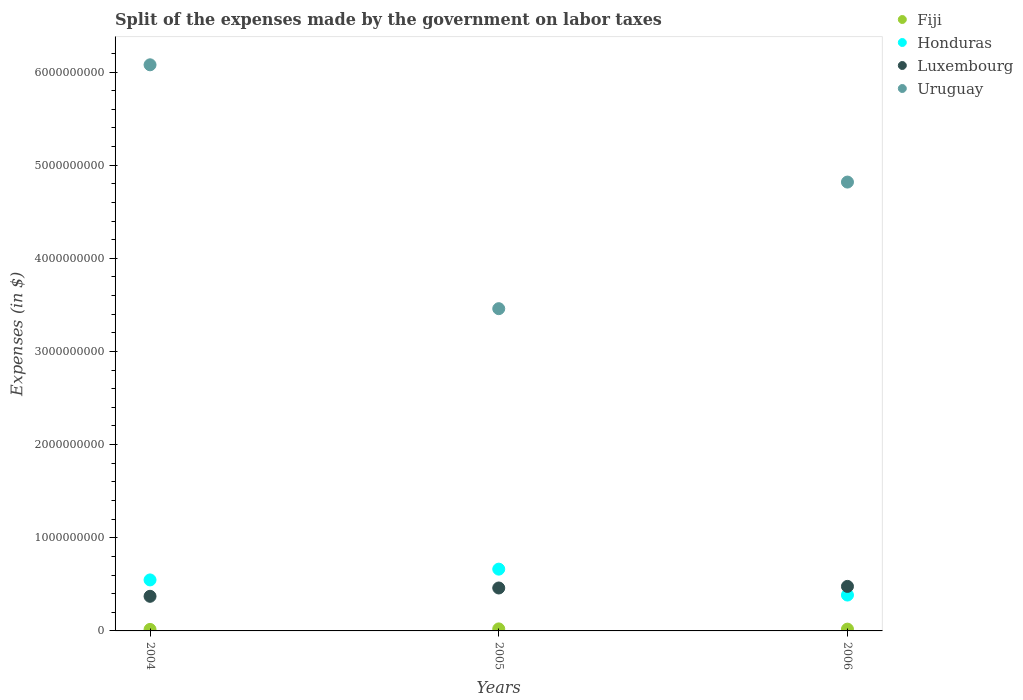How many different coloured dotlines are there?
Offer a very short reply. 4. What is the expenses made by the government on labor taxes in Luxembourg in 2006?
Keep it short and to the point. 4.78e+08. Across all years, what is the maximum expenses made by the government on labor taxes in Uruguay?
Your answer should be compact. 6.08e+09. Across all years, what is the minimum expenses made by the government on labor taxes in Honduras?
Provide a succinct answer. 3.85e+08. In which year was the expenses made by the government on labor taxes in Uruguay maximum?
Make the answer very short. 2004. In which year was the expenses made by the government on labor taxes in Fiji minimum?
Provide a succinct answer. 2004. What is the total expenses made by the government on labor taxes in Honduras in the graph?
Give a very brief answer. 1.60e+09. What is the difference between the expenses made by the government on labor taxes in Honduras in 2004 and that in 2005?
Offer a terse response. -1.16e+08. What is the difference between the expenses made by the government on labor taxes in Uruguay in 2006 and the expenses made by the government on labor taxes in Honduras in 2004?
Keep it short and to the point. 4.27e+09. What is the average expenses made by the government on labor taxes in Fiji per year?
Your answer should be very brief. 1.90e+07. In the year 2005, what is the difference between the expenses made by the government on labor taxes in Uruguay and expenses made by the government on labor taxes in Luxembourg?
Give a very brief answer. 3.00e+09. In how many years, is the expenses made by the government on labor taxes in Luxembourg greater than 6000000000 $?
Make the answer very short. 0. What is the ratio of the expenses made by the government on labor taxes in Uruguay in 2004 to that in 2005?
Ensure brevity in your answer.  1.76. Is the expenses made by the government on labor taxes in Luxembourg in 2005 less than that in 2006?
Ensure brevity in your answer.  Yes. What is the difference between the highest and the second highest expenses made by the government on labor taxes in Fiji?
Your answer should be very brief. 2.51e+06. What is the difference between the highest and the lowest expenses made by the government on labor taxes in Honduras?
Provide a short and direct response. 2.78e+08. In how many years, is the expenses made by the government on labor taxes in Honduras greater than the average expenses made by the government on labor taxes in Honduras taken over all years?
Give a very brief answer. 2. Is the sum of the expenses made by the government on labor taxes in Fiji in 2005 and 2006 greater than the maximum expenses made by the government on labor taxes in Uruguay across all years?
Offer a very short reply. No. Is it the case that in every year, the sum of the expenses made by the government on labor taxes in Fiji and expenses made by the government on labor taxes in Uruguay  is greater than the sum of expenses made by the government on labor taxes in Honduras and expenses made by the government on labor taxes in Luxembourg?
Your answer should be very brief. Yes. Is it the case that in every year, the sum of the expenses made by the government on labor taxes in Fiji and expenses made by the government on labor taxes in Uruguay  is greater than the expenses made by the government on labor taxes in Honduras?
Your answer should be compact. Yes. Does the expenses made by the government on labor taxes in Luxembourg monotonically increase over the years?
Your answer should be very brief. Yes. What is the difference between two consecutive major ticks on the Y-axis?
Give a very brief answer. 1.00e+09. Are the values on the major ticks of Y-axis written in scientific E-notation?
Make the answer very short. No. Does the graph contain grids?
Offer a very short reply. No. Where does the legend appear in the graph?
Offer a terse response. Top right. How are the legend labels stacked?
Your response must be concise. Vertical. What is the title of the graph?
Offer a terse response. Split of the expenses made by the government on labor taxes. What is the label or title of the X-axis?
Give a very brief answer. Years. What is the label or title of the Y-axis?
Provide a short and direct response. Expenses (in $). What is the Expenses (in $) of Fiji in 2004?
Offer a terse response. 1.61e+07. What is the Expenses (in $) in Honduras in 2004?
Make the answer very short. 5.48e+08. What is the Expenses (in $) of Luxembourg in 2004?
Offer a very short reply. 3.72e+08. What is the Expenses (in $) in Uruguay in 2004?
Your answer should be very brief. 6.08e+09. What is the Expenses (in $) in Fiji in 2005?
Your answer should be very brief. 2.17e+07. What is the Expenses (in $) in Honduras in 2005?
Ensure brevity in your answer.  6.63e+08. What is the Expenses (in $) of Luxembourg in 2005?
Your response must be concise. 4.61e+08. What is the Expenses (in $) in Uruguay in 2005?
Your answer should be very brief. 3.46e+09. What is the Expenses (in $) of Fiji in 2006?
Offer a terse response. 1.92e+07. What is the Expenses (in $) in Honduras in 2006?
Provide a succinct answer. 3.85e+08. What is the Expenses (in $) of Luxembourg in 2006?
Provide a succinct answer. 4.78e+08. What is the Expenses (in $) of Uruguay in 2006?
Provide a short and direct response. 4.82e+09. Across all years, what is the maximum Expenses (in $) of Fiji?
Your answer should be compact. 2.17e+07. Across all years, what is the maximum Expenses (in $) in Honduras?
Offer a very short reply. 6.63e+08. Across all years, what is the maximum Expenses (in $) in Luxembourg?
Make the answer very short. 4.78e+08. Across all years, what is the maximum Expenses (in $) in Uruguay?
Your answer should be compact. 6.08e+09. Across all years, what is the minimum Expenses (in $) of Fiji?
Provide a succinct answer. 1.61e+07. Across all years, what is the minimum Expenses (in $) in Honduras?
Provide a succinct answer. 3.85e+08. Across all years, what is the minimum Expenses (in $) of Luxembourg?
Your response must be concise. 3.72e+08. Across all years, what is the minimum Expenses (in $) of Uruguay?
Your answer should be compact. 3.46e+09. What is the total Expenses (in $) in Fiji in the graph?
Your answer should be very brief. 5.69e+07. What is the total Expenses (in $) in Honduras in the graph?
Make the answer very short. 1.60e+09. What is the total Expenses (in $) in Luxembourg in the graph?
Provide a short and direct response. 1.31e+09. What is the total Expenses (in $) in Uruguay in the graph?
Provide a short and direct response. 1.44e+1. What is the difference between the Expenses (in $) in Fiji in 2004 and that in 2005?
Your response must be concise. -5.63e+06. What is the difference between the Expenses (in $) in Honduras in 2004 and that in 2005?
Ensure brevity in your answer.  -1.16e+08. What is the difference between the Expenses (in $) of Luxembourg in 2004 and that in 2005?
Ensure brevity in your answer.  -8.93e+07. What is the difference between the Expenses (in $) in Uruguay in 2004 and that in 2005?
Your response must be concise. 2.62e+09. What is the difference between the Expenses (in $) of Fiji in 2004 and that in 2006?
Your answer should be very brief. -3.12e+06. What is the difference between the Expenses (in $) of Honduras in 2004 and that in 2006?
Give a very brief answer. 1.62e+08. What is the difference between the Expenses (in $) in Luxembourg in 2004 and that in 2006?
Give a very brief answer. -1.06e+08. What is the difference between the Expenses (in $) in Uruguay in 2004 and that in 2006?
Offer a terse response. 1.26e+09. What is the difference between the Expenses (in $) in Fiji in 2005 and that in 2006?
Give a very brief answer. 2.51e+06. What is the difference between the Expenses (in $) of Honduras in 2005 and that in 2006?
Keep it short and to the point. 2.78e+08. What is the difference between the Expenses (in $) in Luxembourg in 2005 and that in 2006?
Offer a terse response. -1.71e+07. What is the difference between the Expenses (in $) of Uruguay in 2005 and that in 2006?
Give a very brief answer. -1.36e+09. What is the difference between the Expenses (in $) of Fiji in 2004 and the Expenses (in $) of Honduras in 2005?
Give a very brief answer. -6.47e+08. What is the difference between the Expenses (in $) in Fiji in 2004 and the Expenses (in $) in Luxembourg in 2005?
Give a very brief answer. -4.45e+08. What is the difference between the Expenses (in $) of Fiji in 2004 and the Expenses (in $) of Uruguay in 2005?
Offer a very short reply. -3.44e+09. What is the difference between the Expenses (in $) of Honduras in 2004 and the Expenses (in $) of Luxembourg in 2005?
Offer a terse response. 8.66e+07. What is the difference between the Expenses (in $) in Honduras in 2004 and the Expenses (in $) in Uruguay in 2005?
Make the answer very short. -2.91e+09. What is the difference between the Expenses (in $) in Luxembourg in 2004 and the Expenses (in $) in Uruguay in 2005?
Provide a short and direct response. -3.09e+09. What is the difference between the Expenses (in $) in Fiji in 2004 and the Expenses (in $) in Honduras in 2006?
Give a very brief answer. -3.69e+08. What is the difference between the Expenses (in $) of Fiji in 2004 and the Expenses (in $) of Luxembourg in 2006?
Your answer should be very brief. -4.62e+08. What is the difference between the Expenses (in $) of Fiji in 2004 and the Expenses (in $) of Uruguay in 2006?
Ensure brevity in your answer.  -4.80e+09. What is the difference between the Expenses (in $) of Honduras in 2004 and the Expenses (in $) of Luxembourg in 2006?
Provide a succinct answer. 6.95e+07. What is the difference between the Expenses (in $) of Honduras in 2004 and the Expenses (in $) of Uruguay in 2006?
Offer a terse response. -4.27e+09. What is the difference between the Expenses (in $) in Luxembourg in 2004 and the Expenses (in $) in Uruguay in 2006?
Offer a terse response. -4.45e+09. What is the difference between the Expenses (in $) in Fiji in 2005 and the Expenses (in $) in Honduras in 2006?
Offer a terse response. -3.63e+08. What is the difference between the Expenses (in $) of Fiji in 2005 and the Expenses (in $) of Luxembourg in 2006?
Give a very brief answer. -4.56e+08. What is the difference between the Expenses (in $) of Fiji in 2005 and the Expenses (in $) of Uruguay in 2006?
Your response must be concise. -4.80e+09. What is the difference between the Expenses (in $) of Honduras in 2005 and the Expenses (in $) of Luxembourg in 2006?
Give a very brief answer. 1.85e+08. What is the difference between the Expenses (in $) in Honduras in 2005 and the Expenses (in $) in Uruguay in 2006?
Your response must be concise. -4.16e+09. What is the difference between the Expenses (in $) of Luxembourg in 2005 and the Expenses (in $) of Uruguay in 2006?
Your answer should be very brief. -4.36e+09. What is the average Expenses (in $) of Fiji per year?
Your answer should be very brief. 1.90e+07. What is the average Expenses (in $) in Honduras per year?
Give a very brief answer. 5.32e+08. What is the average Expenses (in $) of Luxembourg per year?
Keep it short and to the point. 4.37e+08. What is the average Expenses (in $) of Uruguay per year?
Your answer should be compact. 4.79e+09. In the year 2004, what is the difference between the Expenses (in $) of Fiji and Expenses (in $) of Honduras?
Provide a short and direct response. -5.31e+08. In the year 2004, what is the difference between the Expenses (in $) in Fiji and Expenses (in $) in Luxembourg?
Offer a very short reply. -3.56e+08. In the year 2004, what is the difference between the Expenses (in $) of Fiji and Expenses (in $) of Uruguay?
Give a very brief answer. -6.06e+09. In the year 2004, what is the difference between the Expenses (in $) of Honduras and Expenses (in $) of Luxembourg?
Your response must be concise. 1.76e+08. In the year 2004, what is the difference between the Expenses (in $) in Honduras and Expenses (in $) in Uruguay?
Make the answer very short. -5.53e+09. In the year 2004, what is the difference between the Expenses (in $) of Luxembourg and Expenses (in $) of Uruguay?
Your answer should be compact. -5.71e+09. In the year 2005, what is the difference between the Expenses (in $) of Fiji and Expenses (in $) of Honduras?
Offer a very short reply. -6.42e+08. In the year 2005, what is the difference between the Expenses (in $) in Fiji and Expenses (in $) in Luxembourg?
Ensure brevity in your answer.  -4.39e+08. In the year 2005, what is the difference between the Expenses (in $) of Fiji and Expenses (in $) of Uruguay?
Give a very brief answer. -3.44e+09. In the year 2005, what is the difference between the Expenses (in $) in Honduras and Expenses (in $) in Luxembourg?
Your answer should be very brief. 2.02e+08. In the year 2005, what is the difference between the Expenses (in $) of Honduras and Expenses (in $) of Uruguay?
Keep it short and to the point. -2.80e+09. In the year 2005, what is the difference between the Expenses (in $) in Luxembourg and Expenses (in $) in Uruguay?
Provide a succinct answer. -3.00e+09. In the year 2006, what is the difference between the Expenses (in $) in Fiji and Expenses (in $) in Honduras?
Your answer should be compact. -3.66e+08. In the year 2006, what is the difference between the Expenses (in $) in Fiji and Expenses (in $) in Luxembourg?
Your answer should be very brief. -4.59e+08. In the year 2006, what is the difference between the Expenses (in $) of Fiji and Expenses (in $) of Uruguay?
Your answer should be very brief. -4.80e+09. In the year 2006, what is the difference between the Expenses (in $) in Honduras and Expenses (in $) in Luxembourg?
Your answer should be very brief. -9.30e+07. In the year 2006, what is the difference between the Expenses (in $) in Honduras and Expenses (in $) in Uruguay?
Make the answer very short. -4.43e+09. In the year 2006, what is the difference between the Expenses (in $) in Luxembourg and Expenses (in $) in Uruguay?
Provide a short and direct response. -4.34e+09. What is the ratio of the Expenses (in $) of Fiji in 2004 to that in 2005?
Offer a terse response. 0.74. What is the ratio of the Expenses (in $) in Honduras in 2004 to that in 2005?
Provide a short and direct response. 0.83. What is the ratio of the Expenses (in $) in Luxembourg in 2004 to that in 2005?
Offer a terse response. 0.81. What is the ratio of the Expenses (in $) in Uruguay in 2004 to that in 2005?
Keep it short and to the point. 1.76. What is the ratio of the Expenses (in $) in Fiji in 2004 to that in 2006?
Your response must be concise. 0.84. What is the ratio of the Expenses (in $) in Honduras in 2004 to that in 2006?
Your answer should be very brief. 1.42. What is the ratio of the Expenses (in $) in Luxembourg in 2004 to that in 2006?
Your answer should be compact. 0.78. What is the ratio of the Expenses (in $) in Uruguay in 2004 to that in 2006?
Provide a short and direct response. 1.26. What is the ratio of the Expenses (in $) of Fiji in 2005 to that in 2006?
Provide a succinct answer. 1.13. What is the ratio of the Expenses (in $) of Honduras in 2005 to that in 2006?
Your answer should be very brief. 1.72. What is the ratio of the Expenses (in $) of Luxembourg in 2005 to that in 2006?
Your response must be concise. 0.96. What is the ratio of the Expenses (in $) in Uruguay in 2005 to that in 2006?
Offer a very short reply. 0.72. What is the difference between the highest and the second highest Expenses (in $) of Fiji?
Your answer should be compact. 2.51e+06. What is the difference between the highest and the second highest Expenses (in $) of Honduras?
Keep it short and to the point. 1.16e+08. What is the difference between the highest and the second highest Expenses (in $) in Luxembourg?
Ensure brevity in your answer.  1.71e+07. What is the difference between the highest and the second highest Expenses (in $) in Uruguay?
Your response must be concise. 1.26e+09. What is the difference between the highest and the lowest Expenses (in $) of Fiji?
Your answer should be compact. 5.63e+06. What is the difference between the highest and the lowest Expenses (in $) of Honduras?
Your answer should be compact. 2.78e+08. What is the difference between the highest and the lowest Expenses (in $) of Luxembourg?
Keep it short and to the point. 1.06e+08. What is the difference between the highest and the lowest Expenses (in $) of Uruguay?
Your answer should be compact. 2.62e+09. 